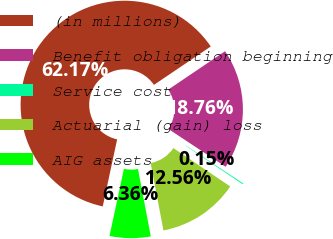Convert chart. <chart><loc_0><loc_0><loc_500><loc_500><pie_chart><fcel>(in millions)<fcel>Benefit obligation beginning<fcel>Service cost<fcel>Actuarial (gain) loss<fcel>AIG assets<nl><fcel>62.17%<fcel>18.76%<fcel>0.15%<fcel>12.56%<fcel>6.36%<nl></chart> 